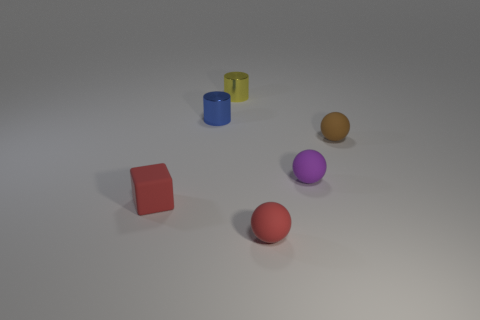Subtract 1 spheres. How many spheres are left? 2 Add 2 tiny purple matte spheres. How many objects exist? 8 Subtract all cylinders. How many objects are left? 4 Add 6 brown balls. How many brown balls are left? 7 Add 5 small blue metallic cylinders. How many small blue metallic cylinders exist? 6 Subtract 1 red blocks. How many objects are left? 5 Subtract all big blue objects. Subtract all yellow shiny cylinders. How many objects are left? 5 